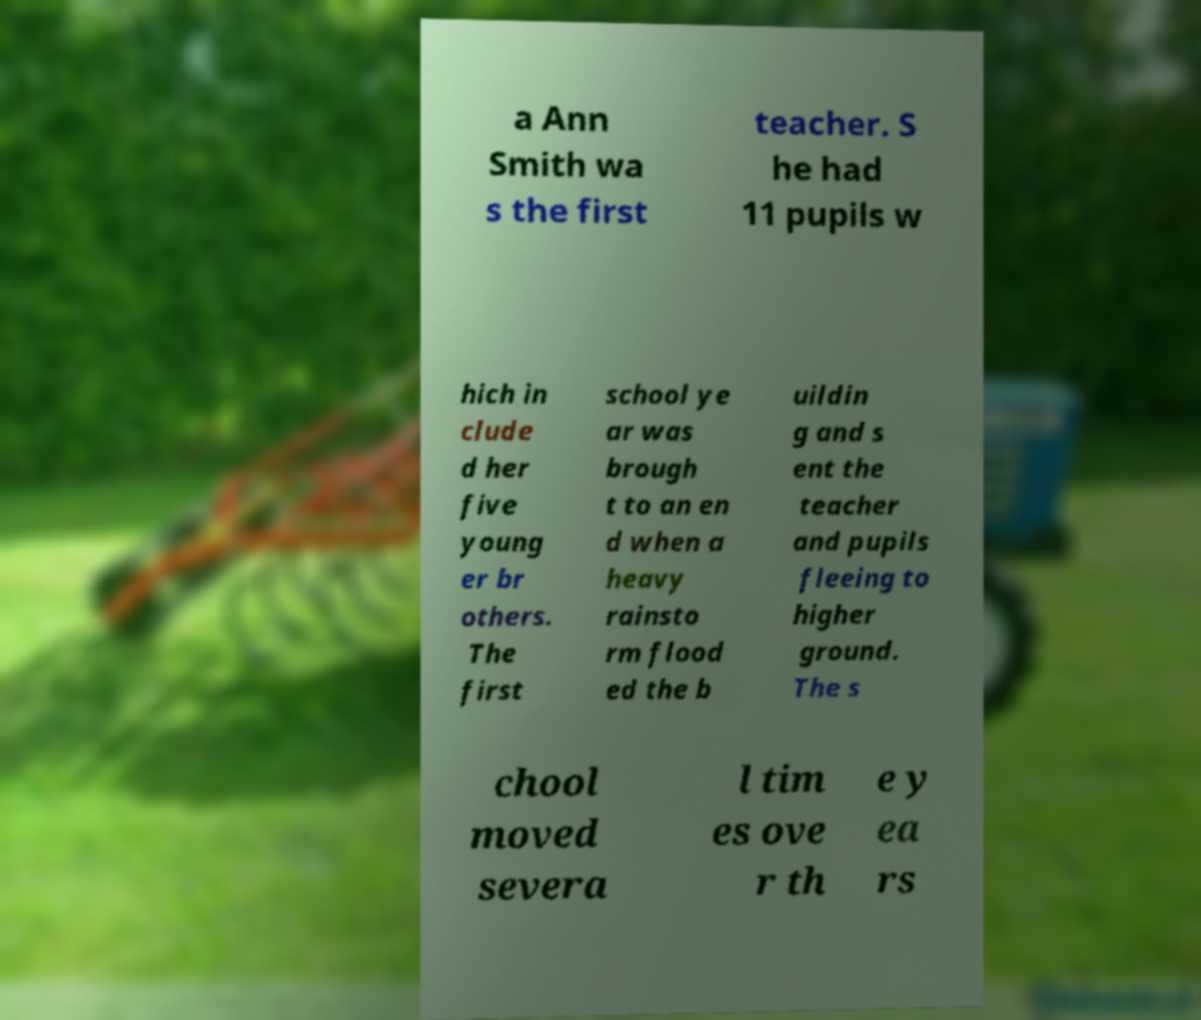Please read and relay the text visible in this image. What does it say? a Ann Smith wa s the first teacher. S he had 11 pupils w hich in clude d her five young er br others. The first school ye ar was brough t to an en d when a heavy rainsto rm flood ed the b uildin g and s ent the teacher and pupils fleeing to higher ground. The s chool moved severa l tim es ove r th e y ea rs 